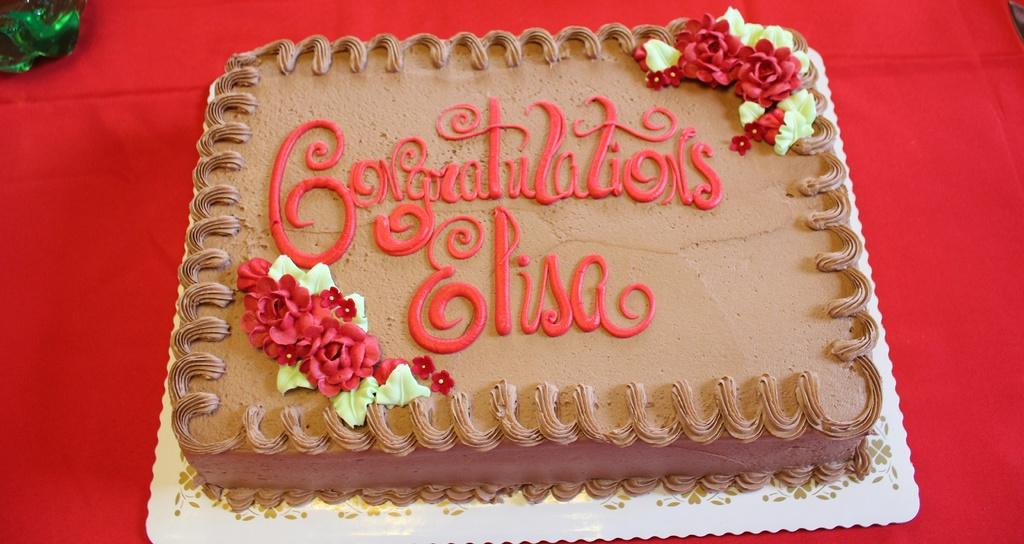What is the main subject of the image? There is a cake in the image. How is the cake presented? The cake is on a serving board. Where is the serving board placed? The serving board is placed on a surface. What can be seen on the left side of the image? There is an object on the left side of the image. How do the brothers taste the cake in the image? There is no mention of brothers in the image, so we cannot determine how they might taste the cake. 